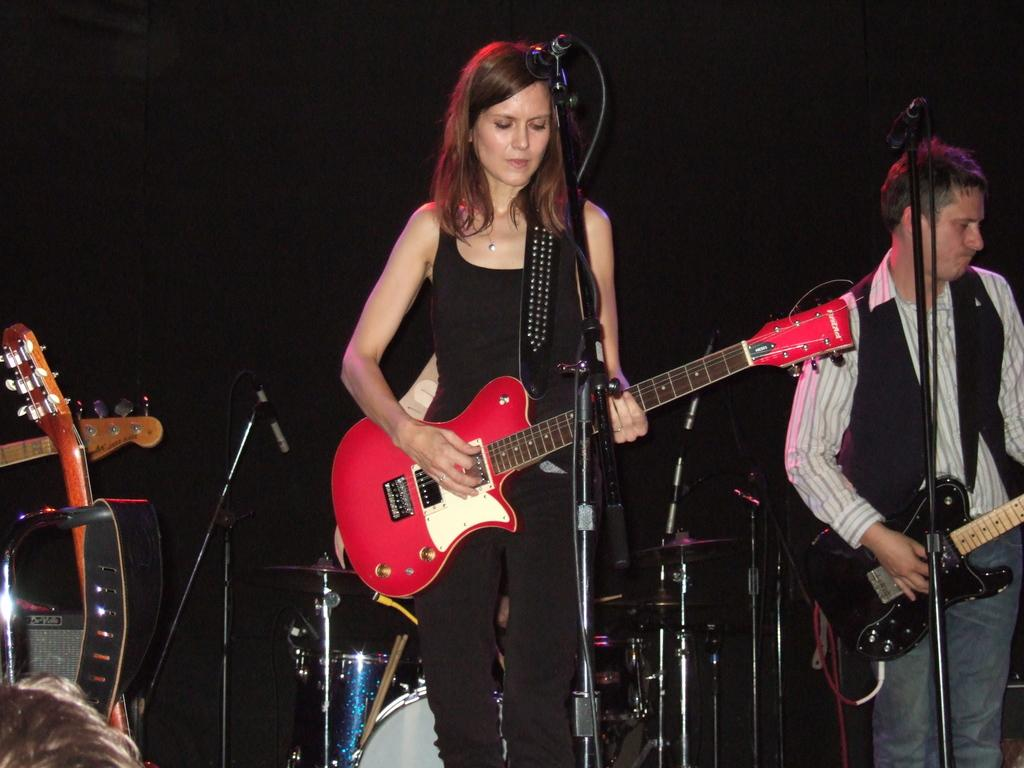What is the woman playing in the image? The woman is playing a guitar. What is the man doing in the image? The man is playing a guitar as well. What object is present in the image that is used for amplifying sound? There is a microphone in the image. What type of objects are the guitar and microphone? The guitar and microphone are musical instruments. What type of quartz can be seen on the guitar in the image? There is no quartz present on the guitar in the image. Is there a fireman playing a guitar in the image? There is no fireman present in the image; both people playing guitars are not firemen. 